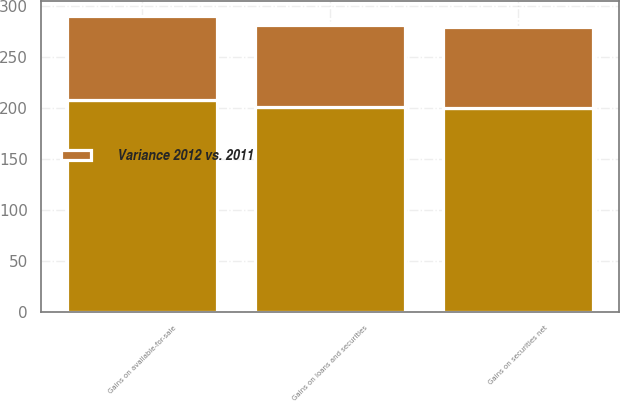<chart> <loc_0><loc_0><loc_500><loc_500><stacked_bar_chart><ecel><fcel>Gains on available-for-sale<fcel>Gains on securities net<fcel>Gains on loans and securities<nl><fcel>nan<fcel>207.3<fcel>199.8<fcel>200.4<nl><fcel>Variance 2012 vs. 2011<fcel>82.9<fcel>79.7<fcel>80.2<nl></chart> 